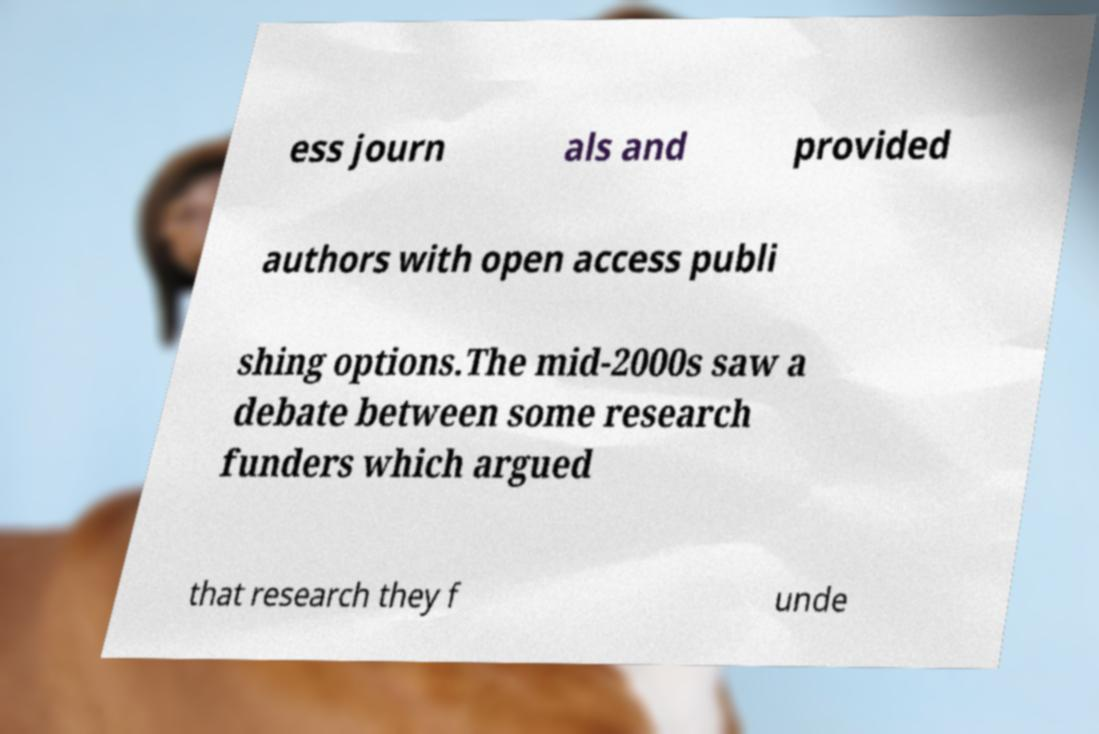For documentation purposes, I need the text within this image transcribed. Could you provide that? ess journ als and provided authors with open access publi shing options.The mid-2000s saw a debate between some research funders which argued that research they f unde 